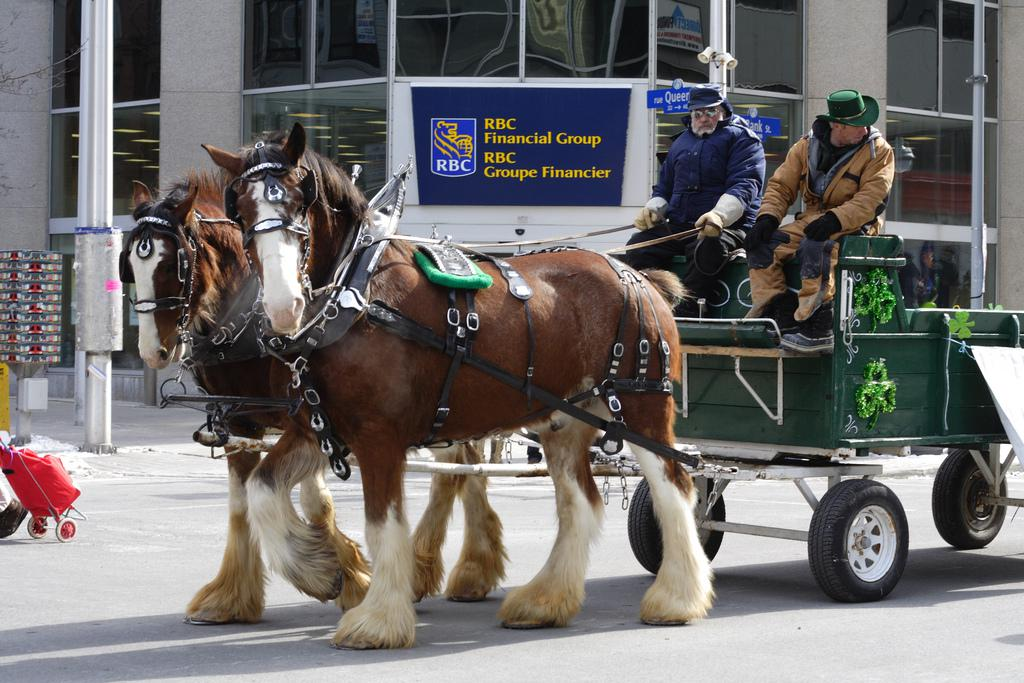Question: what is the total number of shamrocks visible on the cart?
Choices:
A. Six.
B. Seven.
C. Two.
D. One.
Answer with the letter. Answer: C Question: who is holding the reins?
Choices:
A. The man on the right, wearing green.
B. The woman on the left, wearing white.
C. The woman on the right, wearing black.
D. The man on the left, wearing blue.
Answer with the letter. Answer: D Question: who has hold of the reins?
Choices:
A. The woman on the right.
B. The boy in the green.
C. The woman in red.
D. The man on the left.
Answer with the letter. Answer: D Question: why is there green on the horses, the men's hat and the cart?
Choices:
A. They are celebrating May Day.
B. They are celebrating Cinco De Mayo.
C. They are celebrating Mardi Gras.
D. The green is also in honour of St. Patrick's.
Answer with the letter. Answer: D Question: what are both men wearing?
Choices:
A. Cowboy boots.
B. Gloves.
C. Vests and collared shirts.
D. Jeans.
Answer with the letter. Answer: B Question: how many men are seated on the carriage?
Choices:
A. Two.
B. One.
C. Three.
D. Four.
Answer with the letter. Answer: A Question: what part of the clydesdale's faces have white fur on them?
Choices:
A. The upper center.
B. Their noses.
C. Their lower jaw.
D. Their forehead.
Answer with the letter. Answer: B Question: what with wheels is being pushed on the street to the left of the horse cart?
Choices:
A. A bike.
B. A truck.
C. A red cart.
D. A car.
Answer with the letter. Answer: C Question: who has natural furry feet?
Choices:
A. Clydesdale.
B. Dog.
C. The breed of horse.
D. Elmo.
Answer with the letter. Answer: C Question: what does the rbc financial group has?
Choices:
A. Employees.
B. Elevators.
C. A sign.
D. Multi-story building.
Answer with the letter. Answer: D Question: what is one man wearing?
Choices:
A. A green hat.
B. Sunglasses.
C. Earring.
D. Sweater.
Answer with the letter. Answer: A 